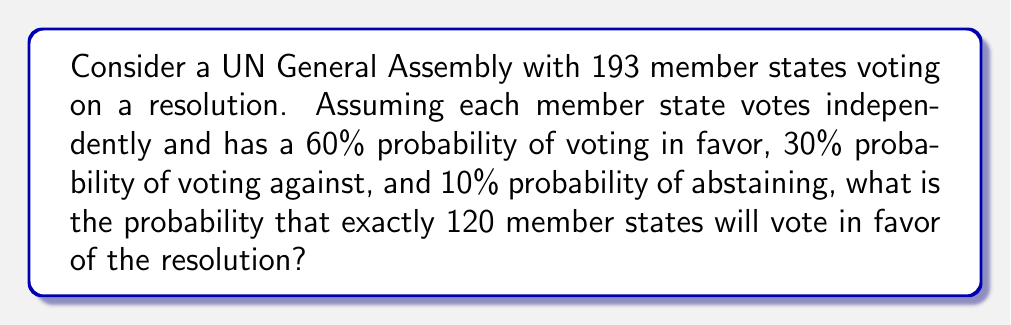Can you answer this question? To solve this problem, we need to use the multinomial distribution, which is an extension of the binomial distribution for more than two outcomes.

Step 1: Identify the parameters
n = 193 (total number of member states)
k = 120 (number of favorable votes we're interested in)
p_favor = 0.60 (probability of voting in favor)
p_against = 0.30 (probability of voting against)
p_abstain = 0.10 (probability of abstaining)

Step 2: Set up the multinomial probability formula
The probability of exactly k successes in n trials is given by:

$$P(X_1 = k_1, X_2 = k_2, X_3 = k_3) = \frac{n!}{k_1!k_2!k_3!} p_1^{k_1} p_2^{k_2} p_3^{k_3}$$

Where:
$X_1$ = number of favorable votes
$X_2$ = number of votes against
$X_3$ = number of abstentions
$k_1 + k_2 + k_3 = n$

Step 3: Calculate the probability
We're interested in $P(X_1 = 120)$, but we need to sum over all possible combinations of votes against and abstentions that add up to 73 (since 120 + 73 = 193).

$$P(X_1 = 120) = \sum_{i=0}^{73} \frac{193!}{120!i!(73-i)!} (0.60)^{120} (0.30)^i (0.10)^{73-i}$$

Step 4: Use a computational tool to calculate the sum
Due to the complexity of this calculation, we would typically use a computer or calculator to evaluate this sum. The result is approximately 0.0416 or 4.16%.
Answer: 0.0416 